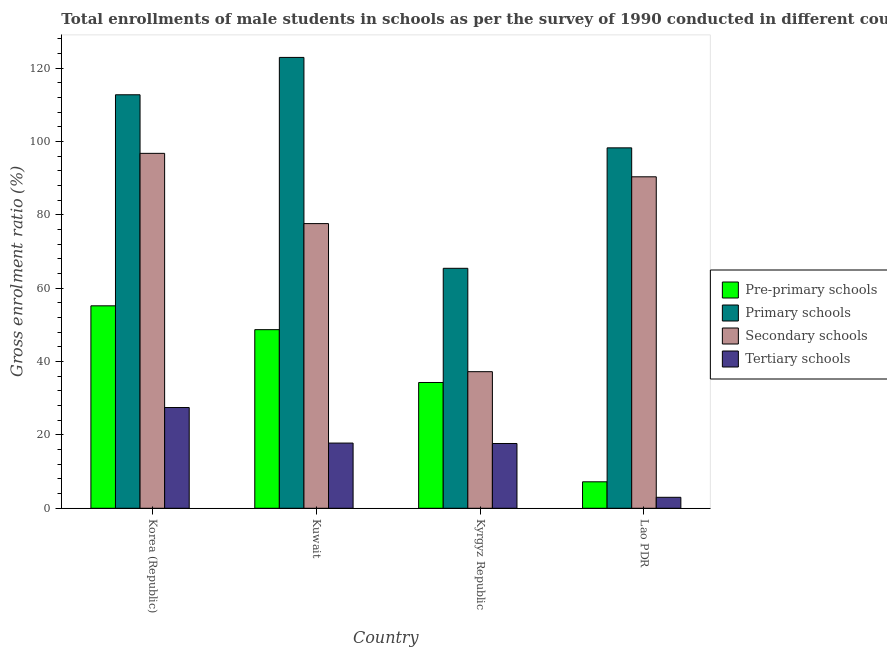Are the number of bars per tick equal to the number of legend labels?
Make the answer very short. Yes. Are the number of bars on each tick of the X-axis equal?
Make the answer very short. Yes. What is the label of the 2nd group of bars from the left?
Your answer should be very brief. Kuwait. What is the gross enrolment ratio(male) in secondary schools in Korea (Republic)?
Make the answer very short. 96.78. Across all countries, what is the maximum gross enrolment ratio(male) in pre-primary schools?
Offer a very short reply. 55.21. Across all countries, what is the minimum gross enrolment ratio(male) in pre-primary schools?
Your answer should be very brief. 7.22. In which country was the gross enrolment ratio(male) in primary schools minimum?
Your response must be concise. Kyrgyz Republic. What is the total gross enrolment ratio(male) in secondary schools in the graph?
Make the answer very short. 302.04. What is the difference between the gross enrolment ratio(male) in secondary schools in Korea (Republic) and that in Lao PDR?
Keep it short and to the point. 6.4. What is the difference between the gross enrolment ratio(male) in primary schools in Kyrgyz Republic and the gross enrolment ratio(male) in secondary schools in Korea (Republic)?
Your answer should be very brief. -31.35. What is the average gross enrolment ratio(male) in pre-primary schools per country?
Your answer should be compact. 36.36. What is the difference between the gross enrolment ratio(male) in pre-primary schools and gross enrolment ratio(male) in primary schools in Korea (Republic)?
Your answer should be very brief. -57.55. What is the ratio of the gross enrolment ratio(male) in primary schools in Korea (Republic) to that in Lao PDR?
Ensure brevity in your answer.  1.15. Is the difference between the gross enrolment ratio(male) in secondary schools in Kuwait and Kyrgyz Republic greater than the difference between the gross enrolment ratio(male) in pre-primary schools in Kuwait and Kyrgyz Republic?
Offer a very short reply. Yes. What is the difference between the highest and the second highest gross enrolment ratio(male) in tertiary schools?
Provide a succinct answer. 9.7. What is the difference between the highest and the lowest gross enrolment ratio(male) in tertiary schools?
Offer a terse response. 24.48. In how many countries, is the gross enrolment ratio(male) in tertiary schools greater than the average gross enrolment ratio(male) in tertiary schools taken over all countries?
Provide a short and direct response. 3. Is the sum of the gross enrolment ratio(male) in secondary schools in Korea (Republic) and Lao PDR greater than the maximum gross enrolment ratio(male) in pre-primary schools across all countries?
Make the answer very short. Yes. What does the 3rd bar from the left in Kuwait represents?
Provide a short and direct response. Secondary schools. What does the 1st bar from the right in Kuwait represents?
Offer a terse response. Tertiary schools. Is it the case that in every country, the sum of the gross enrolment ratio(male) in pre-primary schools and gross enrolment ratio(male) in primary schools is greater than the gross enrolment ratio(male) in secondary schools?
Offer a terse response. Yes. How many countries are there in the graph?
Your response must be concise. 4. What is the difference between two consecutive major ticks on the Y-axis?
Provide a succinct answer. 20. Does the graph contain grids?
Make the answer very short. No. How are the legend labels stacked?
Your answer should be very brief. Vertical. What is the title of the graph?
Offer a very short reply. Total enrollments of male students in schools as per the survey of 1990 conducted in different countries. What is the Gross enrolment ratio (%) of Pre-primary schools in Korea (Republic)?
Your answer should be very brief. 55.21. What is the Gross enrolment ratio (%) in Primary schools in Korea (Republic)?
Ensure brevity in your answer.  112.75. What is the Gross enrolment ratio (%) in Secondary schools in Korea (Republic)?
Your answer should be very brief. 96.78. What is the Gross enrolment ratio (%) in Tertiary schools in Korea (Republic)?
Your answer should be very brief. 27.47. What is the Gross enrolment ratio (%) in Pre-primary schools in Kuwait?
Your answer should be compact. 48.71. What is the Gross enrolment ratio (%) in Primary schools in Kuwait?
Make the answer very short. 122.94. What is the Gross enrolment ratio (%) of Secondary schools in Kuwait?
Ensure brevity in your answer.  77.63. What is the Gross enrolment ratio (%) in Tertiary schools in Kuwait?
Offer a very short reply. 17.78. What is the Gross enrolment ratio (%) of Pre-primary schools in Kyrgyz Republic?
Provide a short and direct response. 34.3. What is the Gross enrolment ratio (%) of Primary schools in Kyrgyz Republic?
Give a very brief answer. 65.44. What is the Gross enrolment ratio (%) in Secondary schools in Kyrgyz Republic?
Your response must be concise. 37.25. What is the Gross enrolment ratio (%) of Tertiary schools in Kyrgyz Republic?
Ensure brevity in your answer.  17.66. What is the Gross enrolment ratio (%) in Pre-primary schools in Lao PDR?
Your answer should be compact. 7.22. What is the Gross enrolment ratio (%) of Primary schools in Lao PDR?
Make the answer very short. 98.28. What is the Gross enrolment ratio (%) of Secondary schools in Lao PDR?
Keep it short and to the point. 90.39. What is the Gross enrolment ratio (%) in Tertiary schools in Lao PDR?
Give a very brief answer. 2.99. Across all countries, what is the maximum Gross enrolment ratio (%) of Pre-primary schools?
Your answer should be very brief. 55.21. Across all countries, what is the maximum Gross enrolment ratio (%) of Primary schools?
Ensure brevity in your answer.  122.94. Across all countries, what is the maximum Gross enrolment ratio (%) of Secondary schools?
Offer a terse response. 96.78. Across all countries, what is the maximum Gross enrolment ratio (%) of Tertiary schools?
Your answer should be very brief. 27.47. Across all countries, what is the minimum Gross enrolment ratio (%) of Pre-primary schools?
Your answer should be very brief. 7.22. Across all countries, what is the minimum Gross enrolment ratio (%) of Primary schools?
Your answer should be compact. 65.44. Across all countries, what is the minimum Gross enrolment ratio (%) of Secondary schools?
Offer a terse response. 37.25. Across all countries, what is the minimum Gross enrolment ratio (%) of Tertiary schools?
Your response must be concise. 2.99. What is the total Gross enrolment ratio (%) of Pre-primary schools in the graph?
Offer a terse response. 145.43. What is the total Gross enrolment ratio (%) in Primary schools in the graph?
Offer a terse response. 399.41. What is the total Gross enrolment ratio (%) of Secondary schools in the graph?
Offer a terse response. 302.04. What is the total Gross enrolment ratio (%) in Tertiary schools in the graph?
Make the answer very short. 65.9. What is the difference between the Gross enrolment ratio (%) of Pre-primary schools in Korea (Republic) and that in Kuwait?
Offer a very short reply. 6.5. What is the difference between the Gross enrolment ratio (%) of Primary schools in Korea (Republic) and that in Kuwait?
Offer a very short reply. -10.19. What is the difference between the Gross enrolment ratio (%) in Secondary schools in Korea (Republic) and that in Kuwait?
Ensure brevity in your answer.  19.16. What is the difference between the Gross enrolment ratio (%) of Tertiary schools in Korea (Republic) and that in Kuwait?
Offer a terse response. 9.7. What is the difference between the Gross enrolment ratio (%) in Pre-primary schools in Korea (Republic) and that in Kyrgyz Republic?
Ensure brevity in your answer.  20.91. What is the difference between the Gross enrolment ratio (%) in Primary schools in Korea (Republic) and that in Kyrgyz Republic?
Your answer should be very brief. 47.32. What is the difference between the Gross enrolment ratio (%) of Secondary schools in Korea (Republic) and that in Kyrgyz Republic?
Ensure brevity in your answer.  59.54. What is the difference between the Gross enrolment ratio (%) of Tertiary schools in Korea (Republic) and that in Kyrgyz Republic?
Your response must be concise. 9.81. What is the difference between the Gross enrolment ratio (%) of Pre-primary schools in Korea (Republic) and that in Lao PDR?
Offer a terse response. 47.99. What is the difference between the Gross enrolment ratio (%) of Primary schools in Korea (Republic) and that in Lao PDR?
Your answer should be very brief. 14.47. What is the difference between the Gross enrolment ratio (%) in Secondary schools in Korea (Republic) and that in Lao PDR?
Give a very brief answer. 6.4. What is the difference between the Gross enrolment ratio (%) of Tertiary schools in Korea (Republic) and that in Lao PDR?
Give a very brief answer. 24.48. What is the difference between the Gross enrolment ratio (%) of Pre-primary schools in Kuwait and that in Kyrgyz Republic?
Your answer should be compact. 14.41. What is the difference between the Gross enrolment ratio (%) of Primary schools in Kuwait and that in Kyrgyz Republic?
Give a very brief answer. 57.51. What is the difference between the Gross enrolment ratio (%) in Secondary schools in Kuwait and that in Kyrgyz Republic?
Your answer should be very brief. 40.38. What is the difference between the Gross enrolment ratio (%) in Tertiary schools in Kuwait and that in Kyrgyz Republic?
Make the answer very short. 0.11. What is the difference between the Gross enrolment ratio (%) in Pre-primary schools in Kuwait and that in Lao PDR?
Your answer should be compact. 41.49. What is the difference between the Gross enrolment ratio (%) in Primary schools in Kuwait and that in Lao PDR?
Your answer should be very brief. 24.66. What is the difference between the Gross enrolment ratio (%) in Secondary schools in Kuwait and that in Lao PDR?
Offer a terse response. -12.76. What is the difference between the Gross enrolment ratio (%) in Tertiary schools in Kuwait and that in Lao PDR?
Ensure brevity in your answer.  14.79. What is the difference between the Gross enrolment ratio (%) in Pre-primary schools in Kyrgyz Republic and that in Lao PDR?
Keep it short and to the point. 27.08. What is the difference between the Gross enrolment ratio (%) of Primary schools in Kyrgyz Republic and that in Lao PDR?
Ensure brevity in your answer.  -32.85. What is the difference between the Gross enrolment ratio (%) in Secondary schools in Kyrgyz Republic and that in Lao PDR?
Offer a very short reply. -53.14. What is the difference between the Gross enrolment ratio (%) in Tertiary schools in Kyrgyz Republic and that in Lao PDR?
Provide a short and direct response. 14.68. What is the difference between the Gross enrolment ratio (%) of Pre-primary schools in Korea (Republic) and the Gross enrolment ratio (%) of Primary schools in Kuwait?
Offer a terse response. -67.74. What is the difference between the Gross enrolment ratio (%) of Pre-primary schools in Korea (Republic) and the Gross enrolment ratio (%) of Secondary schools in Kuwait?
Your answer should be very brief. -22.42. What is the difference between the Gross enrolment ratio (%) of Pre-primary schools in Korea (Republic) and the Gross enrolment ratio (%) of Tertiary schools in Kuwait?
Your answer should be compact. 37.43. What is the difference between the Gross enrolment ratio (%) in Primary schools in Korea (Republic) and the Gross enrolment ratio (%) in Secondary schools in Kuwait?
Keep it short and to the point. 35.13. What is the difference between the Gross enrolment ratio (%) in Primary schools in Korea (Republic) and the Gross enrolment ratio (%) in Tertiary schools in Kuwait?
Offer a terse response. 94.98. What is the difference between the Gross enrolment ratio (%) of Secondary schools in Korea (Republic) and the Gross enrolment ratio (%) of Tertiary schools in Kuwait?
Give a very brief answer. 79.01. What is the difference between the Gross enrolment ratio (%) in Pre-primary schools in Korea (Republic) and the Gross enrolment ratio (%) in Primary schools in Kyrgyz Republic?
Make the answer very short. -10.23. What is the difference between the Gross enrolment ratio (%) of Pre-primary schools in Korea (Republic) and the Gross enrolment ratio (%) of Secondary schools in Kyrgyz Republic?
Offer a very short reply. 17.96. What is the difference between the Gross enrolment ratio (%) in Pre-primary schools in Korea (Republic) and the Gross enrolment ratio (%) in Tertiary schools in Kyrgyz Republic?
Offer a very short reply. 37.54. What is the difference between the Gross enrolment ratio (%) of Primary schools in Korea (Republic) and the Gross enrolment ratio (%) of Secondary schools in Kyrgyz Republic?
Provide a succinct answer. 75.51. What is the difference between the Gross enrolment ratio (%) in Primary schools in Korea (Republic) and the Gross enrolment ratio (%) in Tertiary schools in Kyrgyz Republic?
Ensure brevity in your answer.  95.09. What is the difference between the Gross enrolment ratio (%) in Secondary schools in Korea (Republic) and the Gross enrolment ratio (%) in Tertiary schools in Kyrgyz Republic?
Provide a succinct answer. 79.12. What is the difference between the Gross enrolment ratio (%) of Pre-primary schools in Korea (Republic) and the Gross enrolment ratio (%) of Primary schools in Lao PDR?
Keep it short and to the point. -43.08. What is the difference between the Gross enrolment ratio (%) in Pre-primary schools in Korea (Republic) and the Gross enrolment ratio (%) in Secondary schools in Lao PDR?
Offer a very short reply. -35.18. What is the difference between the Gross enrolment ratio (%) in Pre-primary schools in Korea (Republic) and the Gross enrolment ratio (%) in Tertiary schools in Lao PDR?
Your answer should be very brief. 52.22. What is the difference between the Gross enrolment ratio (%) of Primary schools in Korea (Republic) and the Gross enrolment ratio (%) of Secondary schools in Lao PDR?
Provide a succinct answer. 22.37. What is the difference between the Gross enrolment ratio (%) of Primary schools in Korea (Republic) and the Gross enrolment ratio (%) of Tertiary schools in Lao PDR?
Offer a terse response. 109.77. What is the difference between the Gross enrolment ratio (%) of Secondary schools in Korea (Republic) and the Gross enrolment ratio (%) of Tertiary schools in Lao PDR?
Offer a very short reply. 93.79. What is the difference between the Gross enrolment ratio (%) in Pre-primary schools in Kuwait and the Gross enrolment ratio (%) in Primary schools in Kyrgyz Republic?
Offer a very short reply. -16.73. What is the difference between the Gross enrolment ratio (%) in Pre-primary schools in Kuwait and the Gross enrolment ratio (%) in Secondary schools in Kyrgyz Republic?
Provide a short and direct response. 11.46. What is the difference between the Gross enrolment ratio (%) of Pre-primary schools in Kuwait and the Gross enrolment ratio (%) of Tertiary schools in Kyrgyz Republic?
Offer a terse response. 31.04. What is the difference between the Gross enrolment ratio (%) in Primary schools in Kuwait and the Gross enrolment ratio (%) in Secondary schools in Kyrgyz Republic?
Your answer should be compact. 85.7. What is the difference between the Gross enrolment ratio (%) in Primary schools in Kuwait and the Gross enrolment ratio (%) in Tertiary schools in Kyrgyz Republic?
Your response must be concise. 105.28. What is the difference between the Gross enrolment ratio (%) in Secondary schools in Kuwait and the Gross enrolment ratio (%) in Tertiary schools in Kyrgyz Republic?
Make the answer very short. 59.96. What is the difference between the Gross enrolment ratio (%) in Pre-primary schools in Kuwait and the Gross enrolment ratio (%) in Primary schools in Lao PDR?
Offer a very short reply. -49.58. What is the difference between the Gross enrolment ratio (%) in Pre-primary schools in Kuwait and the Gross enrolment ratio (%) in Secondary schools in Lao PDR?
Provide a short and direct response. -41.68. What is the difference between the Gross enrolment ratio (%) of Pre-primary schools in Kuwait and the Gross enrolment ratio (%) of Tertiary schools in Lao PDR?
Ensure brevity in your answer.  45.72. What is the difference between the Gross enrolment ratio (%) of Primary schools in Kuwait and the Gross enrolment ratio (%) of Secondary schools in Lao PDR?
Provide a succinct answer. 32.55. What is the difference between the Gross enrolment ratio (%) of Primary schools in Kuwait and the Gross enrolment ratio (%) of Tertiary schools in Lao PDR?
Provide a short and direct response. 119.95. What is the difference between the Gross enrolment ratio (%) of Secondary schools in Kuwait and the Gross enrolment ratio (%) of Tertiary schools in Lao PDR?
Give a very brief answer. 74.64. What is the difference between the Gross enrolment ratio (%) of Pre-primary schools in Kyrgyz Republic and the Gross enrolment ratio (%) of Primary schools in Lao PDR?
Offer a terse response. -63.98. What is the difference between the Gross enrolment ratio (%) in Pre-primary schools in Kyrgyz Republic and the Gross enrolment ratio (%) in Secondary schools in Lao PDR?
Your answer should be compact. -56.09. What is the difference between the Gross enrolment ratio (%) in Pre-primary schools in Kyrgyz Republic and the Gross enrolment ratio (%) in Tertiary schools in Lao PDR?
Provide a short and direct response. 31.31. What is the difference between the Gross enrolment ratio (%) in Primary schools in Kyrgyz Republic and the Gross enrolment ratio (%) in Secondary schools in Lao PDR?
Provide a short and direct response. -24.95. What is the difference between the Gross enrolment ratio (%) of Primary schools in Kyrgyz Republic and the Gross enrolment ratio (%) of Tertiary schools in Lao PDR?
Your answer should be compact. 62.45. What is the difference between the Gross enrolment ratio (%) of Secondary schools in Kyrgyz Republic and the Gross enrolment ratio (%) of Tertiary schools in Lao PDR?
Offer a very short reply. 34.26. What is the average Gross enrolment ratio (%) in Pre-primary schools per country?
Your response must be concise. 36.36. What is the average Gross enrolment ratio (%) of Primary schools per country?
Provide a short and direct response. 99.85. What is the average Gross enrolment ratio (%) in Secondary schools per country?
Ensure brevity in your answer.  75.51. What is the average Gross enrolment ratio (%) of Tertiary schools per country?
Offer a terse response. 16.48. What is the difference between the Gross enrolment ratio (%) in Pre-primary schools and Gross enrolment ratio (%) in Primary schools in Korea (Republic)?
Keep it short and to the point. -57.55. What is the difference between the Gross enrolment ratio (%) of Pre-primary schools and Gross enrolment ratio (%) of Secondary schools in Korea (Republic)?
Provide a short and direct response. -41.58. What is the difference between the Gross enrolment ratio (%) in Pre-primary schools and Gross enrolment ratio (%) in Tertiary schools in Korea (Republic)?
Your answer should be very brief. 27.73. What is the difference between the Gross enrolment ratio (%) in Primary schools and Gross enrolment ratio (%) in Secondary schools in Korea (Republic)?
Ensure brevity in your answer.  15.97. What is the difference between the Gross enrolment ratio (%) of Primary schools and Gross enrolment ratio (%) of Tertiary schools in Korea (Republic)?
Offer a terse response. 85.28. What is the difference between the Gross enrolment ratio (%) in Secondary schools and Gross enrolment ratio (%) in Tertiary schools in Korea (Republic)?
Your response must be concise. 69.31. What is the difference between the Gross enrolment ratio (%) of Pre-primary schools and Gross enrolment ratio (%) of Primary schools in Kuwait?
Your response must be concise. -74.24. What is the difference between the Gross enrolment ratio (%) of Pre-primary schools and Gross enrolment ratio (%) of Secondary schools in Kuwait?
Offer a very short reply. -28.92. What is the difference between the Gross enrolment ratio (%) in Pre-primary schools and Gross enrolment ratio (%) in Tertiary schools in Kuwait?
Make the answer very short. 30.93. What is the difference between the Gross enrolment ratio (%) in Primary schools and Gross enrolment ratio (%) in Secondary schools in Kuwait?
Keep it short and to the point. 45.32. What is the difference between the Gross enrolment ratio (%) of Primary schools and Gross enrolment ratio (%) of Tertiary schools in Kuwait?
Keep it short and to the point. 105.17. What is the difference between the Gross enrolment ratio (%) of Secondary schools and Gross enrolment ratio (%) of Tertiary schools in Kuwait?
Give a very brief answer. 59.85. What is the difference between the Gross enrolment ratio (%) of Pre-primary schools and Gross enrolment ratio (%) of Primary schools in Kyrgyz Republic?
Make the answer very short. -31.14. What is the difference between the Gross enrolment ratio (%) in Pre-primary schools and Gross enrolment ratio (%) in Secondary schools in Kyrgyz Republic?
Give a very brief answer. -2.95. What is the difference between the Gross enrolment ratio (%) of Pre-primary schools and Gross enrolment ratio (%) of Tertiary schools in Kyrgyz Republic?
Give a very brief answer. 16.63. What is the difference between the Gross enrolment ratio (%) in Primary schools and Gross enrolment ratio (%) in Secondary schools in Kyrgyz Republic?
Your response must be concise. 28.19. What is the difference between the Gross enrolment ratio (%) in Primary schools and Gross enrolment ratio (%) in Tertiary schools in Kyrgyz Republic?
Keep it short and to the point. 47.77. What is the difference between the Gross enrolment ratio (%) of Secondary schools and Gross enrolment ratio (%) of Tertiary schools in Kyrgyz Republic?
Give a very brief answer. 19.58. What is the difference between the Gross enrolment ratio (%) in Pre-primary schools and Gross enrolment ratio (%) in Primary schools in Lao PDR?
Your response must be concise. -91.06. What is the difference between the Gross enrolment ratio (%) of Pre-primary schools and Gross enrolment ratio (%) of Secondary schools in Lao PDR?
Your answer should be very brief. -83.17. What is the difference between the Gross enrolment ratio (%) in Pre-primary schools and Gross enrolment ratio (%) in Tertiary schools in Lao PDR?
Your answer should be very brief. 4.23. What is the difference between the Gross enrolment ratio (%) of Primary schools and Gross enrolment ratio (%) of Secondary schools in Lao PDR?
Your answer should be compact. 7.89. What is the difference between the Gross enrolment ratio (%) of Primary schools and Gross enrolment ratio (%) of Tertiary schools in Lao PDR?
Keep it short and to the point. 95.29. What is the difference between the Gross enrolment ratio (%) in Secondary schools and Gross enrolment ratio (%) in Tertiary schools in Lao PDR?
Keep it short and to the point. 87.4. What is the ratio of the Gross enrolment ratio (%) of Pre-primary schools in Korea (Republic) to that in Kuwait?
Offer a terse response. 1.13. What is the ratio of the Gross enrolment ratio (%) in Primary schools in Korea (Republic) to that in Kuwait?
Your answer should be very brief. 0.92. What is the ratio of the Gross enrolment ratio (%) in Secondary schools in Korea (Republic) to that in Kuwait?
Provide a succinct answer. 1.25. What is the ratio of the Gross enrolment ratio (%) of Tertiary schools in Korea (Republic) to that in Kuwait?
Your response must be concise. 1.55. What is the ratio of the Gross enrolment ratio (%) of Pre-primary schools in Korea (Republic) to that in Kyrgyz Republic?
Your answer should be very brief. 1.61. What is the ratio of the Gross enrolment ratio (%) in Primary schools in Korea (Republic) to that in Kyrgyz Republic?
Make the answer very short. 1.72. What is the ratio of the Gross enrolment ratio (%) of Secondary schools in Korea (Republic) to that in Kyrgyz Republic?
Keep it short and to the point. 2.6. What is the ratio of the Gross enrolment ratio (%) in Tertiary schools in Korea (Republic) to that in Kyrgyz Republic?
Your answer should be compact. 1.56. What is the ratio of the Gross enrolment ratio (%) in Pre-primary schools in Korea (Republic) to that in Lao PDR?
Keep it short and to the point. 7.65. What is the ratio of the Gross enrolment ratio (%) of Primary schools in Korea (Republic) to that in Lao PDR?
Offer a very short reply. 1.15. What is the ratio of the Gross enrolment ratio (%) in Secondary schools in Korea (Republic) to that in Lao PDR?
Keep it short and to the point. 1.07. What is the ratio of the Gross enrolment ratio (%) in Tertiary schools in Korea (Republic) to that in Lao PDR?
Ensure brevity in your answer.  9.19. What is the ratio of the Gross enrolment ratio (%) in Pre-primary schools in Kuwait to that in Kyrgyz Republic?
Give a very brief answer. 1.42. What is the ratio of the Gross enrolment ratio (%) in Primary schools in Kuwait to that in Kyrgyz Republic?
Make the answer very short. 1.88. What is the ratio of the Gross enrolment ratio (%) in Secondary schools in Kuwait to that in Kyrgyz Republic?
Provide a succinct answer. 2.08. What is the ratio of the Gross enrolment ratio (%) of Tertiary schools in Kuwait to that in Kyrgyz Republic?
Give a very brief answer. 1.01. What is the ratio of the Gross enrolment ratio (%) of Pre-primary schools in Kuwait to that in Lao PDR?
Make the answer very short. 6.75. What is the ratio of the Gross enrolment ratio (%) of Primary schools in Kuwait to that in Lao PDR?
Your answer should be very brief. 1.25. What is the ratio of the Gross enrolment ratio (%) of Secondary schools in Kuwait to that in Lao PDR?
Your response must be concise. 0.86. What is the ratio of the Gross enrolment ratio (%) in Tertiary schools in Kuwait to that in Lao PDR?
Provide a succinct answer. 5.95. What is the ratio of the Gross enrolment ratio (%) of Pre-primary schools in Kyrgyz Republic to that in Lao PDR?
Provide a succinct answer. 4.75. What is the ratio of the Gross enrolment ratio (%) in Primary schools in Kyrgyz Republic to that in Lao PDR?
Give a very brief answer. 0.67. What is the ratio of the Gross enrolment ratio (%) in Secondary schools in Kyrgyz Republic to that in Lao PDR?
Your answer should be compact. 0.41. What is the ratio of the Gross enrolment ratio (%) in Tertiary schools in Kyrgyz Republic to that in Lao PDR?
Your response must be concise. 5.91. What is the difference between the highest and the second highest Gross enrolment ratio (%) of Pre-primary schools?
Offer a terse response. 6.5. What is the difference between the highest and the second highest Gross enrolment ratio (%) in Primary schools?
Offer a terse response. 10.19. What is the difference between the highest and the second highest Gross enrolment ratio (%) in Secondary schools?
Keep it short and to the point. 6.4. What is the difference between the highest and the second highest Gross enrolment ratio (%) in Tertiary schools?
Offer a terse response. 9.7. What is the difference between the highest and the lowest Gross enrolment ratio (%) in Pre-primary schools?
Give a very brief answer. 47.99. What is the difference between the highest and the lowest Gross enrolment ratio (%) of Primary schools?
Keep it short and to the point. 57.51. What is the difference between the highest and the lowest Gross enrolment ratio (%) in Secondary schools?
Your answer should be compact. 59.54. What is the difference between the highest and the lowest Gross enrolment ratio (%) of Tertiary schools?
Give a very brief answer. 24.48. 